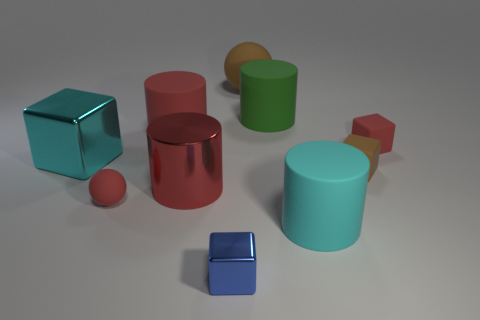How many cylinders are in front of the metallic thing that is to the left of the small rubber object left of the big matte sphere?
Keep it short and to the point. 2. There is a brown object that is the same shape as the large cyan metal object; what is it made of?
Your answer should be very brief. Rubber. What is the large object that is both in front of the small red rubber block and to the left of the large metallic cylinder made of?
Keep it short and to the point. Metal. Is the number of tiny rubber blocks to the right of the tiny brown rubber block less than the number of red objects that are behind the big brown sphere?
Make the answer very short. No. What number of other things are there of the same size as the red metal object?
Make the answer very short. 5. There is a cyan object that is to the left of the red matte object in front of the red rubber object that is to the right of the cyan cylinder; what is its shape?
Provide a short and direct response. Cube. How many cyan objects are either large cylinders or large metallic things?
Your response must be concise. 2. How many large green rubber objects are in front of the shiny block on the right side of the small red rubber ball?
Give a very brief answer. 0. Is there anything else that has the same color as the tiny rubber ball?
Provide a succinct answer. Yes. There is a cyan thing that is the same material as the brown sphere; what is its shape?
Your answer should be very brief. Cylinder. 